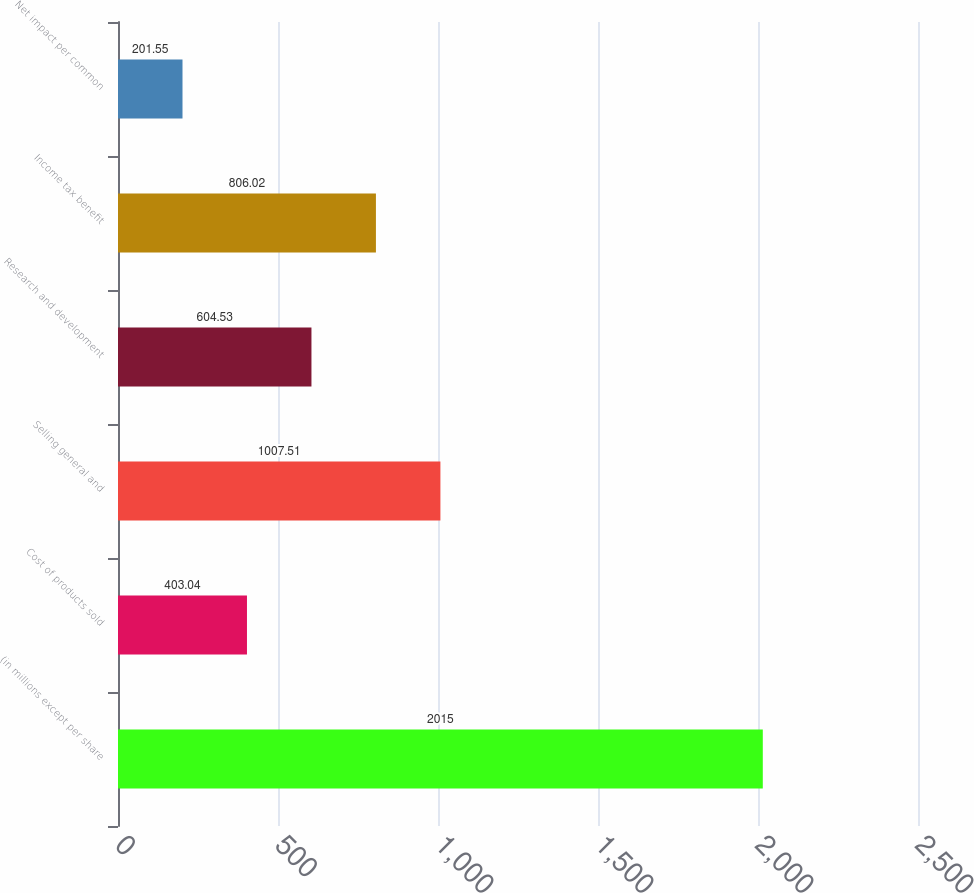Convert chart. <chart><loc_0><loc_0><loc_500><loc_500><bar_chart><fcel>(in millions except per share<fcel>Cost of products sold<fcel>Selling general and<fcel>Research and development<fcel>Income tax benefit<fcel>Net impact per common<nl><fcel>2015<fcel>403.04<fcel>1007.51<fcel>604.53<fcel>806.02<fcel>201.55<nl></chart> 